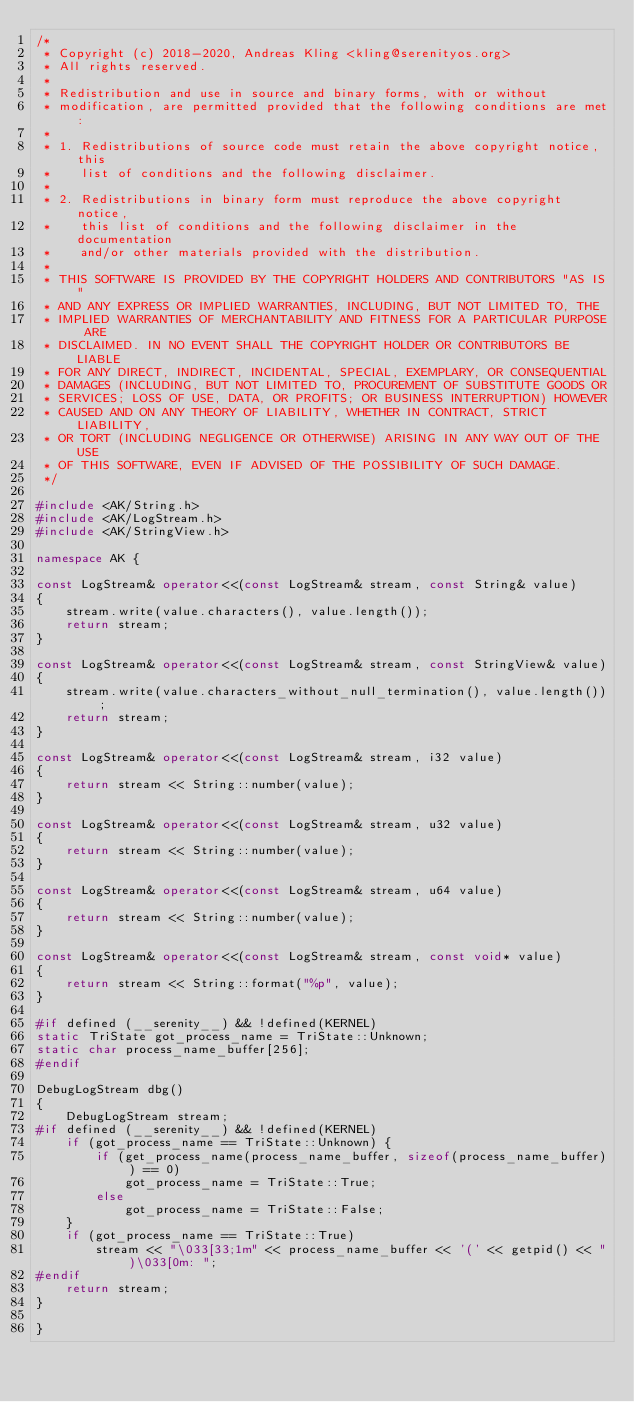Convert code to text. <code><loc_0><loc_0><loc_500><loc_500><_C++_>/*
 * Copyright (c) 2018-2020, Andreas Kling <kling@serenityos.org>
 * All rights reserved.
 *
 * Redistribution and use in source and binary forms, with or without
 * modification, are permitted provided that the following conditions are met:
 *
 * 1. Redistributions of source code must retain the above copyright notice, this
 *    list of conditions and the following disclaimer.
 *
 * 2. Redistributions in binary form must reproduce the above copyright notice,
 *    this list of conditions and the following disclaimer in the documentation
 *    and/or other materials provided with the distribution.
 *
 * THIS SOFTWARE IS PROVIDED BY THE COPYRIGHT HOLDERS AND CONTRIBUTORS "AS IS"
 * AND ANY EXPRESS OR IMPLIED WARRANTIES, INCLUDING, BUT NOT LIMITED TO, THE
 * IMPLIED WARRANTIES OF MERCHANTABILITY AND FITNESS FOR A PARTICULAR PURPOSE ARE
 * DISCLAIMED. IN NO EVENT SHALL THE COPYRIGHT HOLDER OR CONTRIBUTORS BE LIABLE
 * FOR ANY DIRECT, INDIRECT, INCIDENTAL, SPECIAL, EXEMPLARY, OR CONSEQUENTIAL
 * DAMAGES (INCLUDING, BUT NOT LIMITED TO, PROCUREMENT OF SUBSTITUTE GOODS OR
 * SERVICES; LOSS OF USE, DATA, OR PROFITS; OR BUSINESS INTERRUPTION) HOWEVER
 * CAUSED AND ON ANY THEORY OF LIABILITY, WHETHER IN CONTRACT, STRICT LIABILITY,
 * OR TORT (INCLUDING NEGLIGENCE OR OTHERWISE) ARISING IN ANY WAY OUT OF THE USE
 * OF THIS SOFTWARE, EVEN IF ADVISED OF THE POSSIBILITY OF SUCH DAMAGE.
 */

#include <AK/String.h>
#include <AK/LogStream.h>
#include <AK/StringView.h>

namespace AK {

const LogStream& operator<<(const LogStream& stream, const String& value)
{
    stream.write(value.characters(), value.length());
    return stream;
}

const LogStream& operator<<(const LogStream& stream, const StringView& value)
{
    stream.write(value.characters_without_null_termination(), value.length());
    return stream;
}

const LogStream& operator<<(const LogStream& stream, i32 value)
{
    return stream << String::number(value);
}

const LogStream& operator<<(const LogStream& stream, u32 value)
{
    return stream << String::number(value);
}

const LogStream& operator<<(const LogStream& stream, u64 value)
{
    return stream << String::number(value);
}

const LogStream& operator<<(const LogStream& stream, const void* value)
{
    return stream << String::format("%p", value);
}

#if defined (__serenity__) && !defined(KERNEL)
static TriState got_process_name = TriState::Unknown;
static char process_name_buffer[256];
#endif

DebugLogStream dbg()
{
    DebugLogStream stream;
#if defined (__serenity__) && !defined(KERNEL)
    if (got_process_name == TriState::Unknown) {
        if (get_process_name(process_name_buffer, sizeof(process_name_buffer)) == 0)
            got_process_name = TriState::True;
        else
            got_process_name = TriState::False;
    }
    if (got_process_name == TriState::True)
        stream << "\033[33;1m" << process_name_buffer << '(' << getpid() << ")\033[0m: ";
#endif
    return stream;
}

}
</code> 